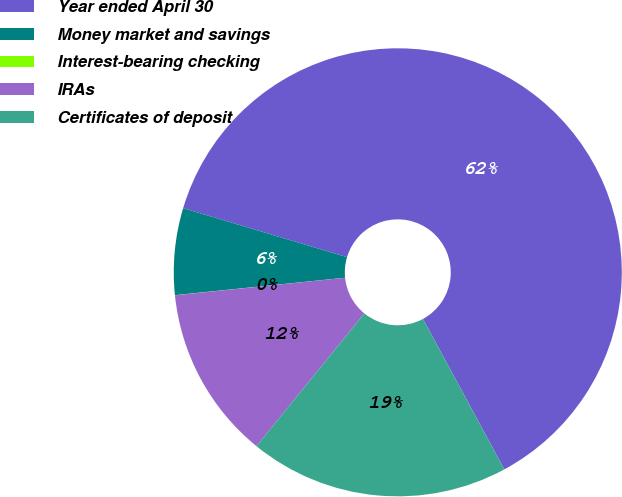Convert chart. <chart><loc_0><loc_0><loc_500><loc_500><pie_chart><fcel>Year ended April 30<fcel>Money market and savings<fcel>Interest-bearing checking<fcel>IRAs<fcel>Certificates of deposit<nl><fcel>62.49%<fcel>6.25%<fcel>0.01%<fcel>12.5%<fcel>18.75%<nl></chart> 